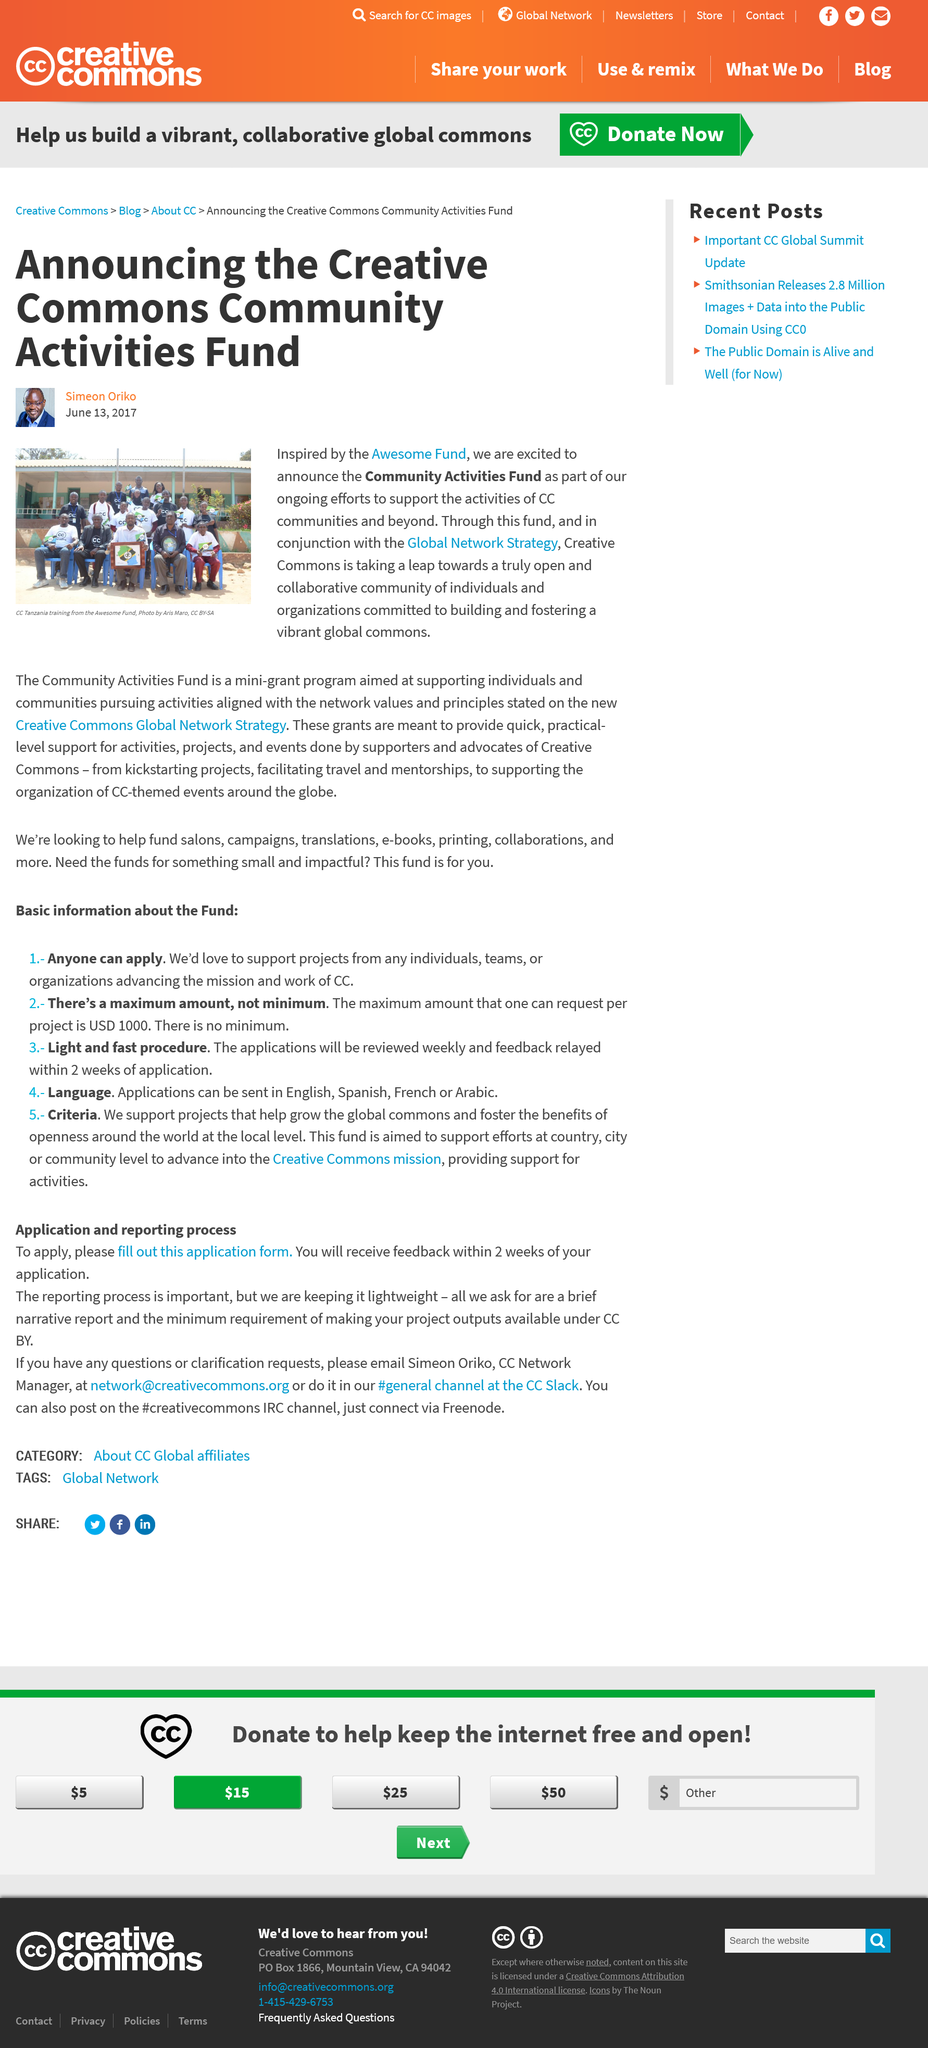Specify some key components in this picture. On June 13, 2017, Simeon Oriko announced the CC Activities Found. The Community Activities Fund was inspired by the Awesome Foundation, The Community Activities Fund is designated to provide financial assistance to Community Councils for the purpose of supporting their activities. 